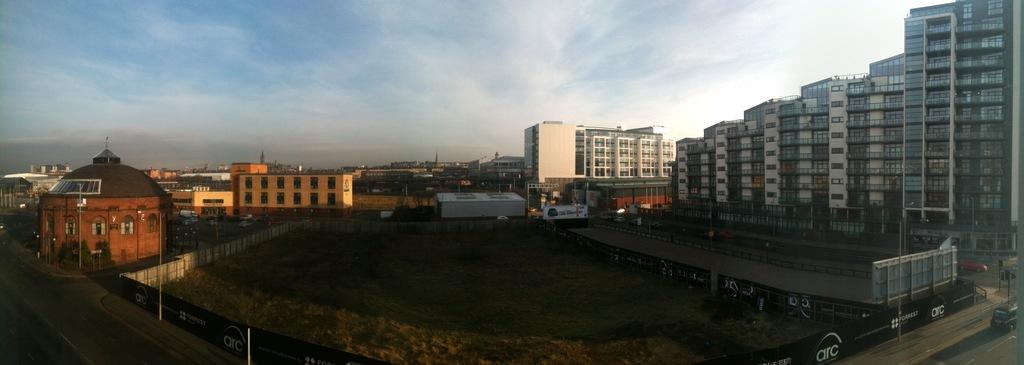What type of structures are present in the image? There are buildings in the image. What other natural elements can be seen in the image? There are trees in the image. What are the vertical structures in the image used for? There are poles in the image, which are likely used for supporting power lines or other utilities. What can be seen on the right side of the image? There are vehicles on the right side of the image. Where are the vehicles located? The vehicles are on a road. What is visible in the background of the image? There is sky visible in the background of the image. Can you see a guitar being played in the image? There is no guitar present in the image. How does the image change when you look at it from a different angle? The image does not change when viewed from different angles, as it is a static image. 